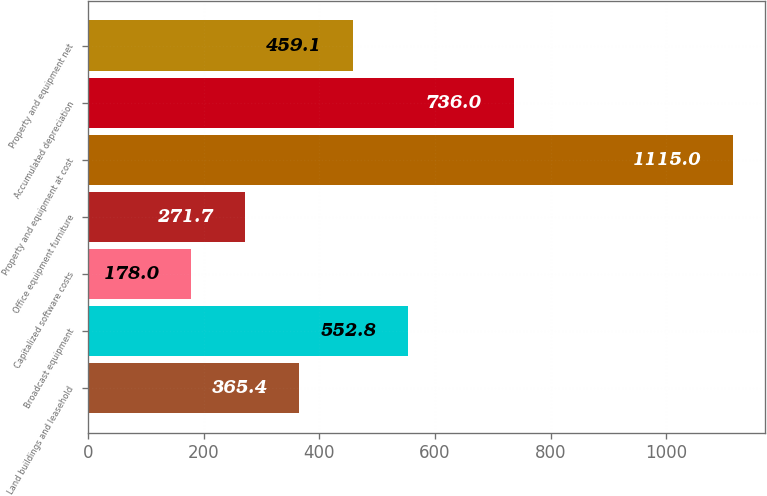<chart> <loc_0><loc_0><loc_500><loc_500><bar_chart><fcel>Land buildings and leasehold<fcel>Broadcast equipment<fcel>Capitalized software costs<fcel>Office equipment furniture<fcel>Property and equipment at cost<fcel>Accumulated depreciation<fcel>Property and equipment net<nl><fcel>365.4<fcel>552.8<fcel>178<fcel>271.7<fcel>1115<fcel>736<fcel>459.1<nl></chart> 